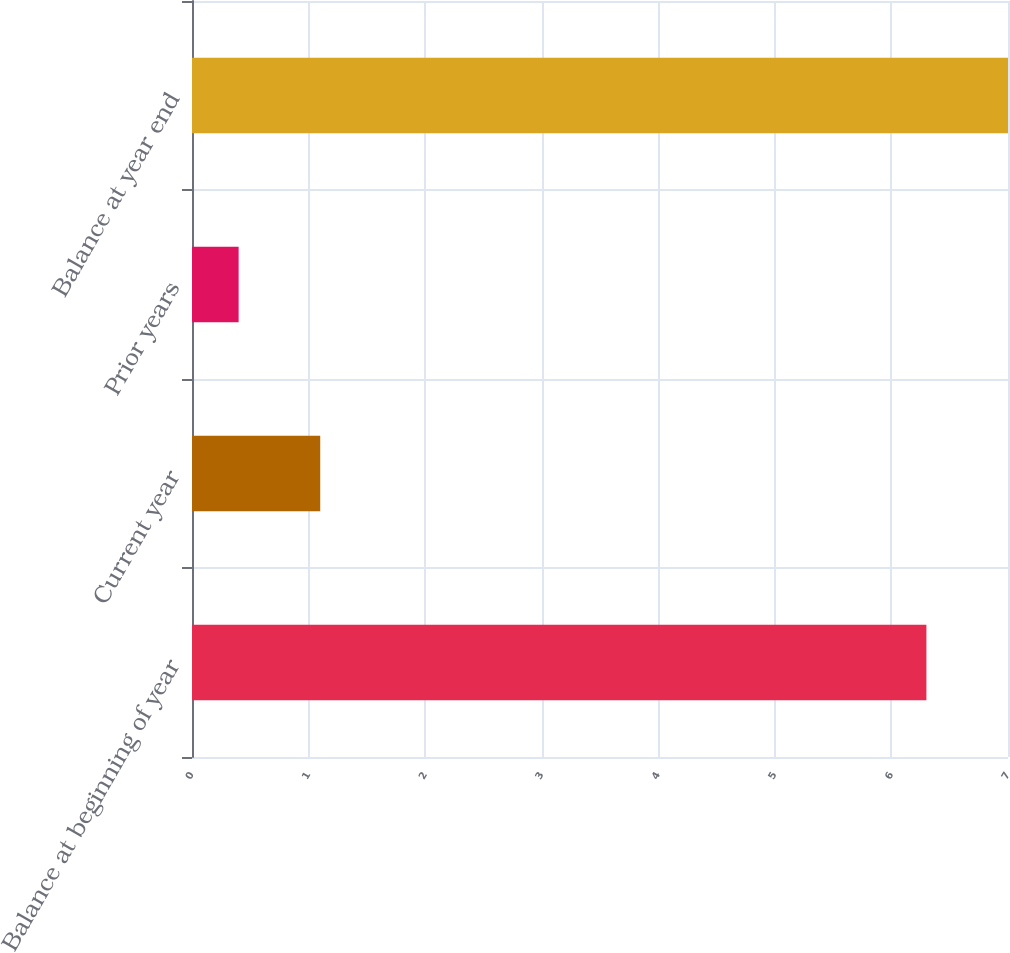Convert chart to OTSL. <chart><loc_0><loc_0><loc_500><loc_500><bar_chart><fcel>Balance at beginning of year<fcel>Current year<fcel>Prior years<fcel>Balance at year end<nl><fcel>6.3<fcel>1.1<fcel>0.4<fcel>7<nl></chart> 